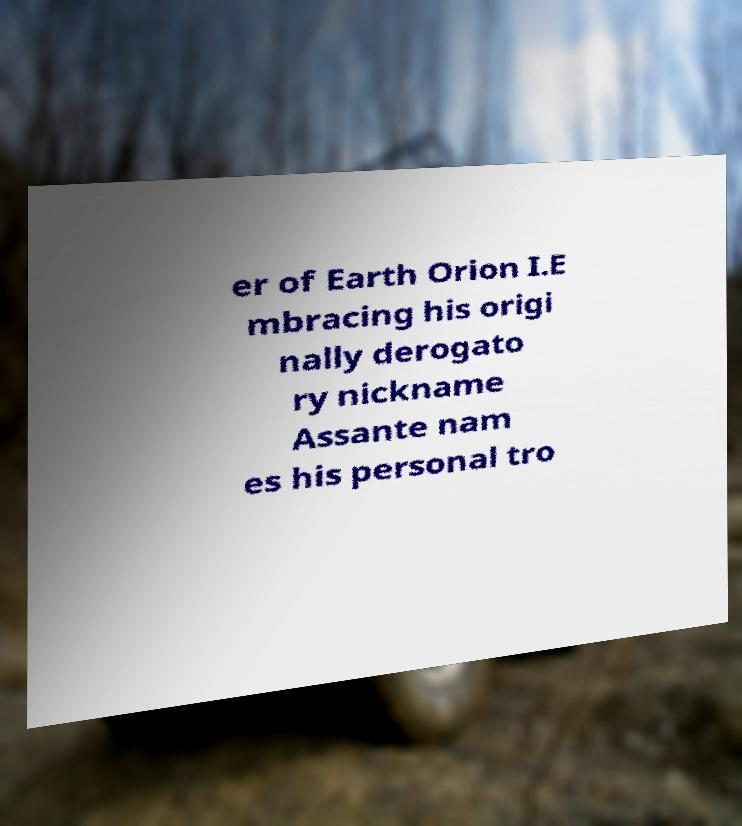Could you extract and type out the text from this image? er of Earth Orion I.E mbracing his origi nally derogato ry nickname Assante nam es his personal tro 